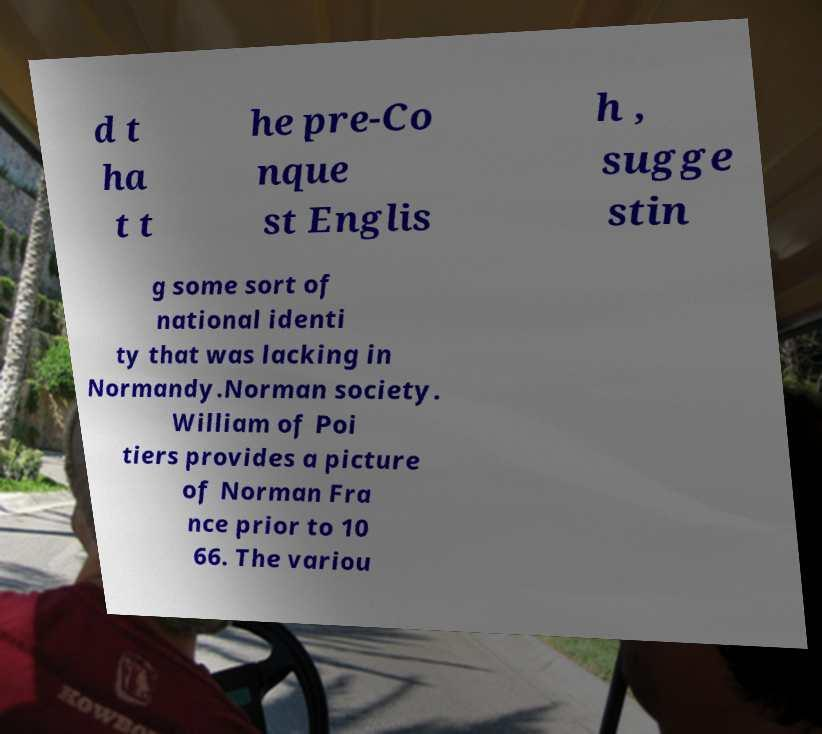Please read and relay the text visible in this image. What does it say? d t ha t t he pre-Co nque st Englis h , sugge stin g some sort of national identi ty that was lacking in Normandy.Norman society. William of Poi tiers provides a picture of Norman Fra nce prior to 10 66. The variou 